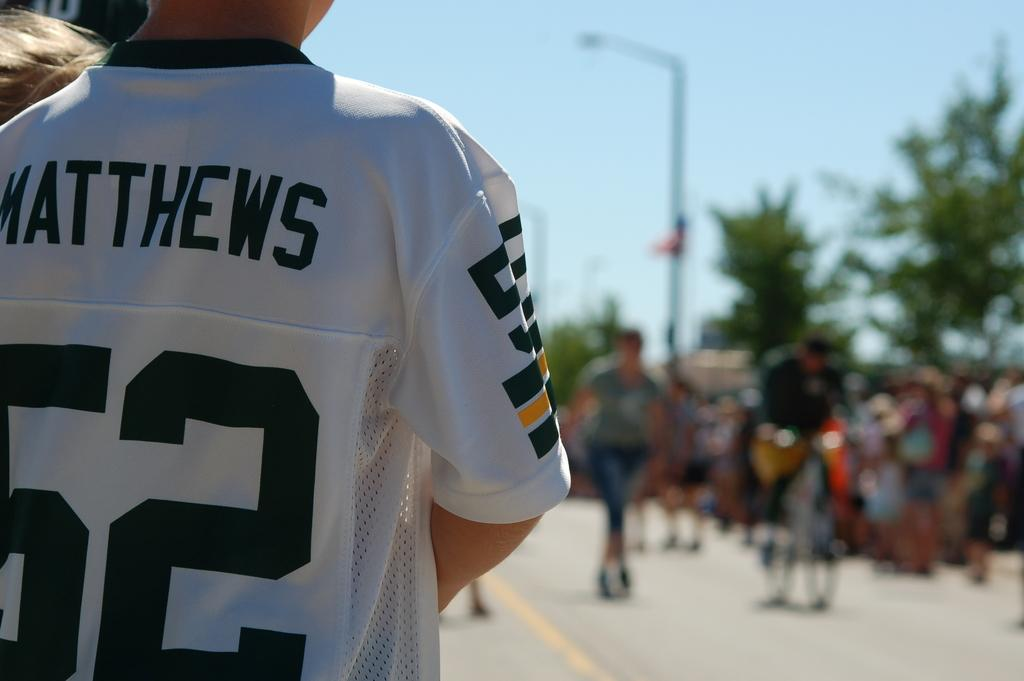Provide a one-sentence caption for the provided image. A boy in a white jersey that says Matthews 62 appears to be watching a parade. 